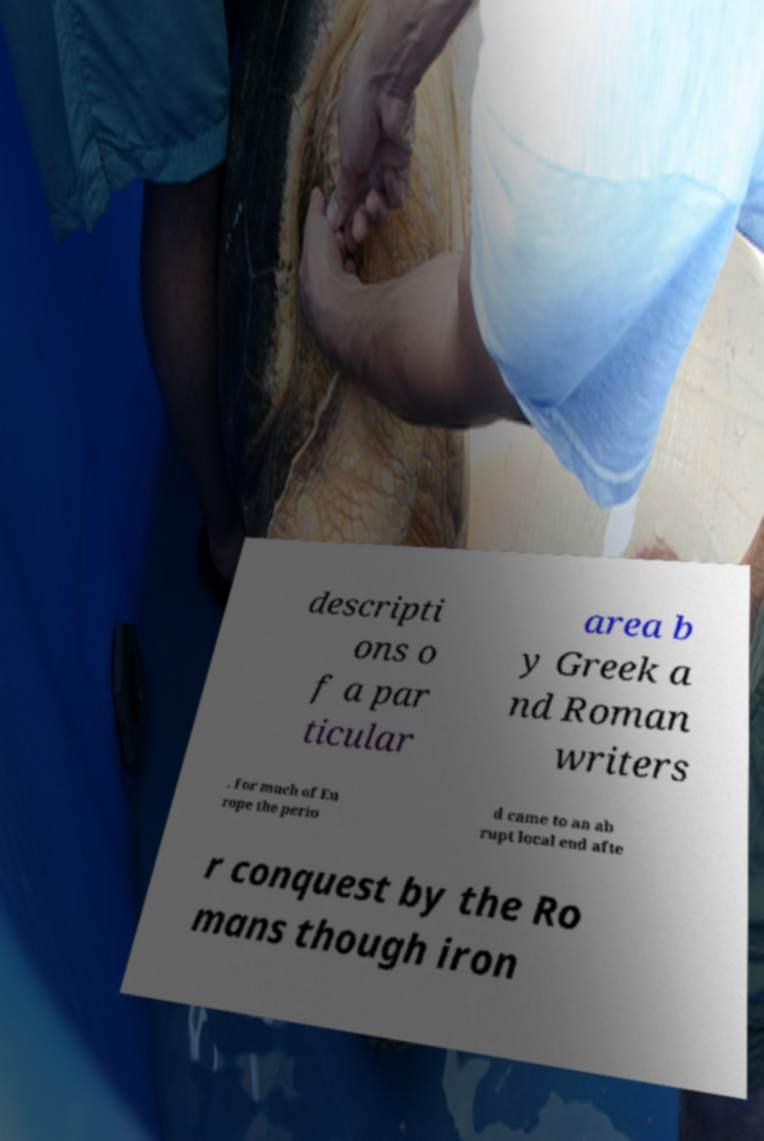There's text embedded in this image that I need extracted. Can you transcribe it verbatim? descripti ons o f a par ticular area b y Greek a nd Roman writers . For much of Eu rope the perio d came to an ab rupt local end afte r conquest by the Ro mans though iron 